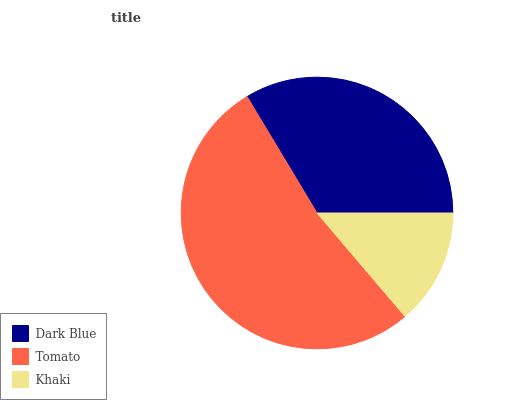Is Khaki the minimum?
Answer yes or no. Yes. Is Tomato the maximum?
Answer yes or no. Yes. Is Tomato the minimum?
Answer yes or no. No. Is Khaki the maximum?
Answer yes or no. No. Is Tomato greater than Khaki?
Answer yes or no. Yes. Is Khaki less than Tomato?
Answer yes or no. Yes. Is Khaki greater than Tomato?
Answer yes or no. No. Is Tomato less than Khaki?
Answer yes or no. No. Is Dark Blue the high median?
Answer yes or no. Yes. Is Dark Blue the low median?
Answer yes or no. Yes. Is Khaki the high median?
Answer yes or no. No. Is Tomato the low median?
Answer yes or no. No. 